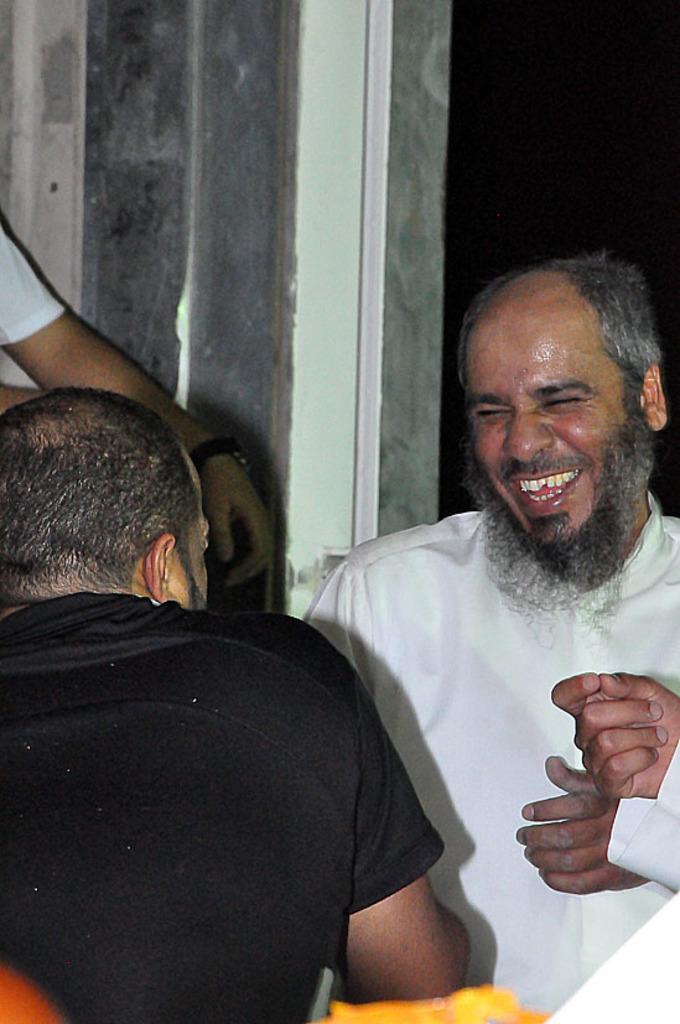How would you summarize this image in a sentence or two? In this picture I can see there are two men sitting and there is a person sitting at the right side, he is wearing a white shirt and laughing and there is a man sitting in front of him. There is a wall in the backdrop and the rest of the image is dark at the right side. 